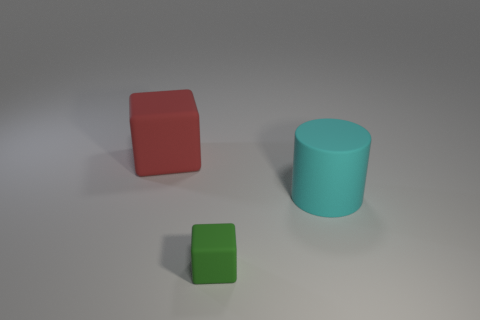Add 1 purple matte cubes. How many objects exist? 4 Subtract all blocks. How many objects are left? 1 Add 2 cyan cylinders. How many cyan cylinders are left? 3 Add 1 big cylinders. How many big cylinders exist? 2 Subtract 0 yellow cylinders. How many objects are left? 3 Subtract all big green rubber blocks. Subtract all rubber things. How many objects are left? 0 